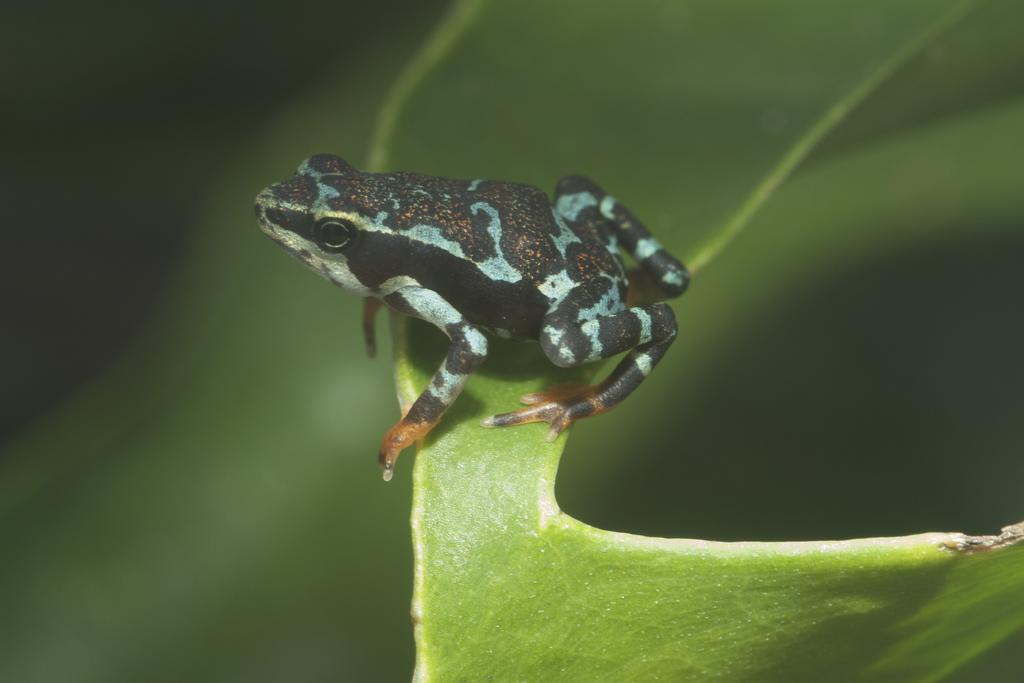What type of animal is in the image? There is a frog in the image. Where is the frog located? The frog is present on a leaf. What type of corn is being harvested in the image? There is no corn present in the image; it features a frog on a leaf. What sound does the frog make in the image? The image is still, so it does not depict any sounds being made by the frog. 